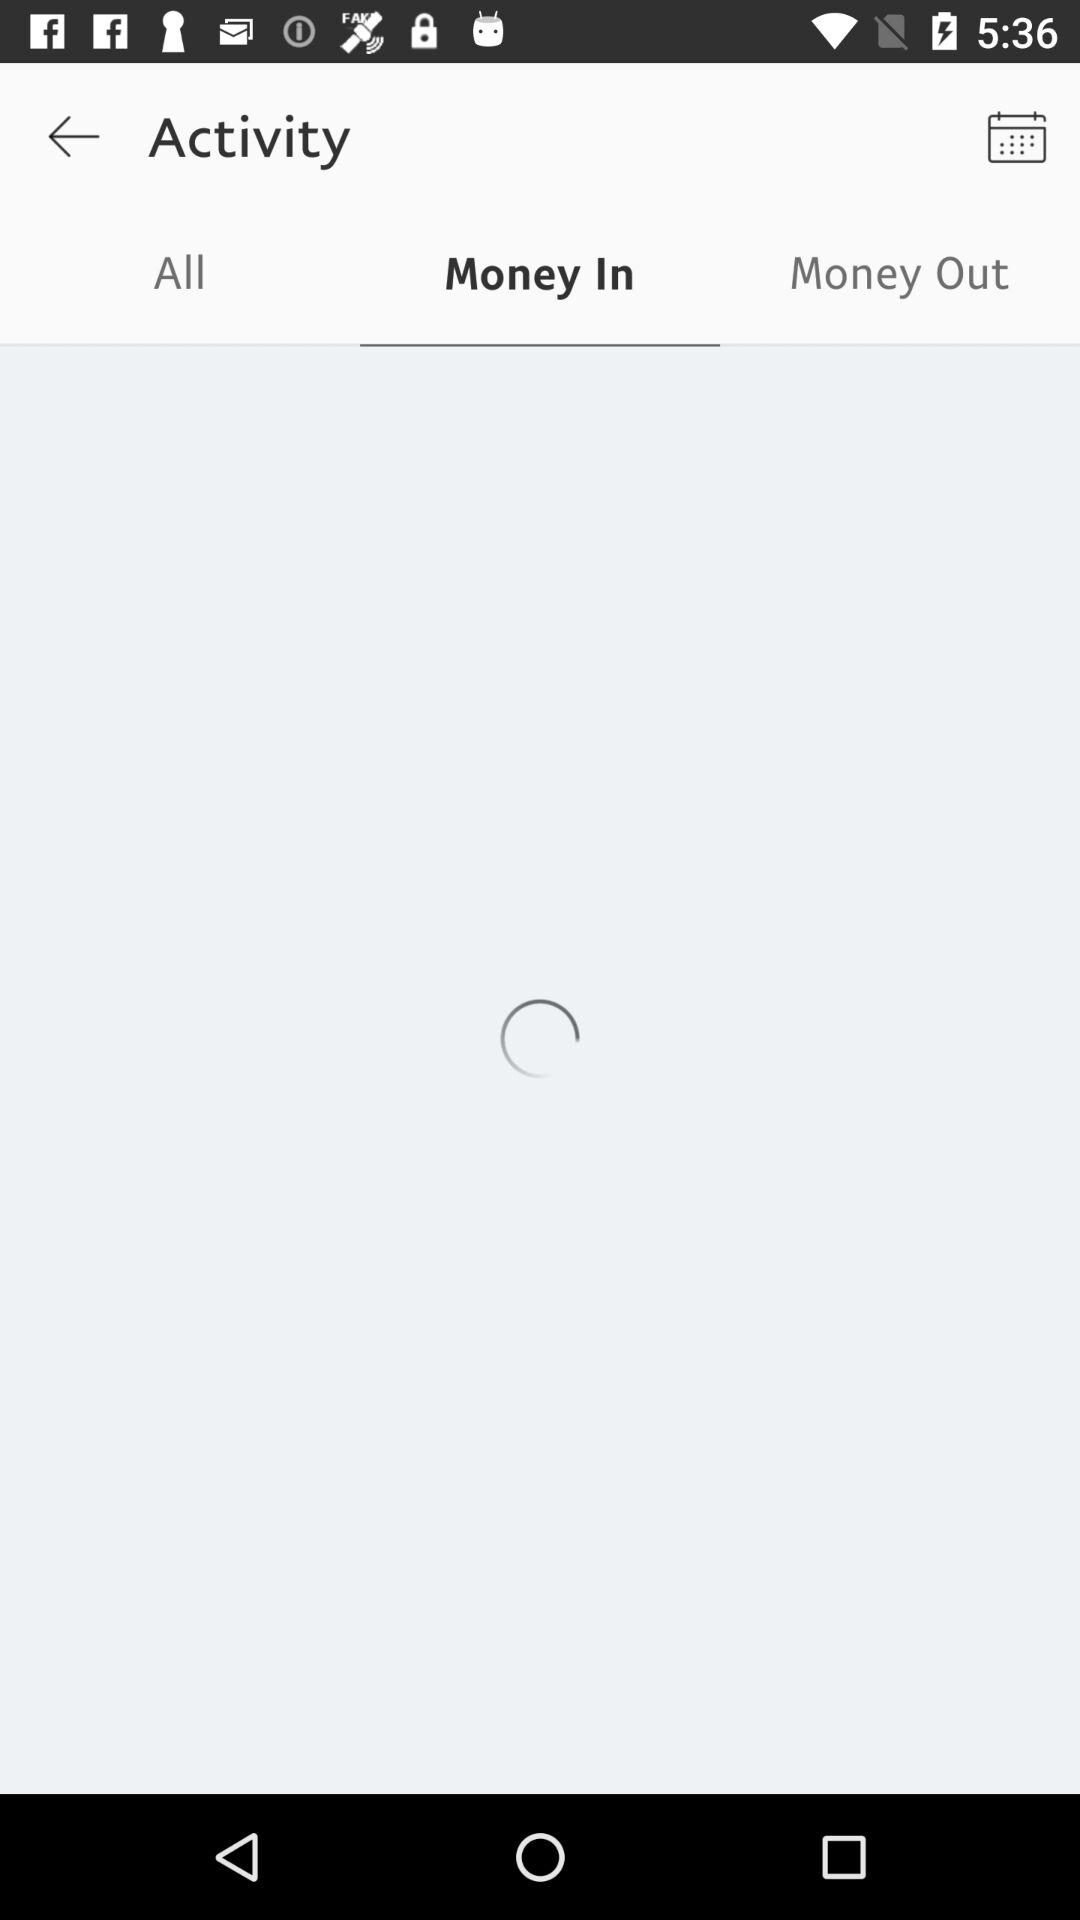Which tab is selected? The selected tab is "Money In". 